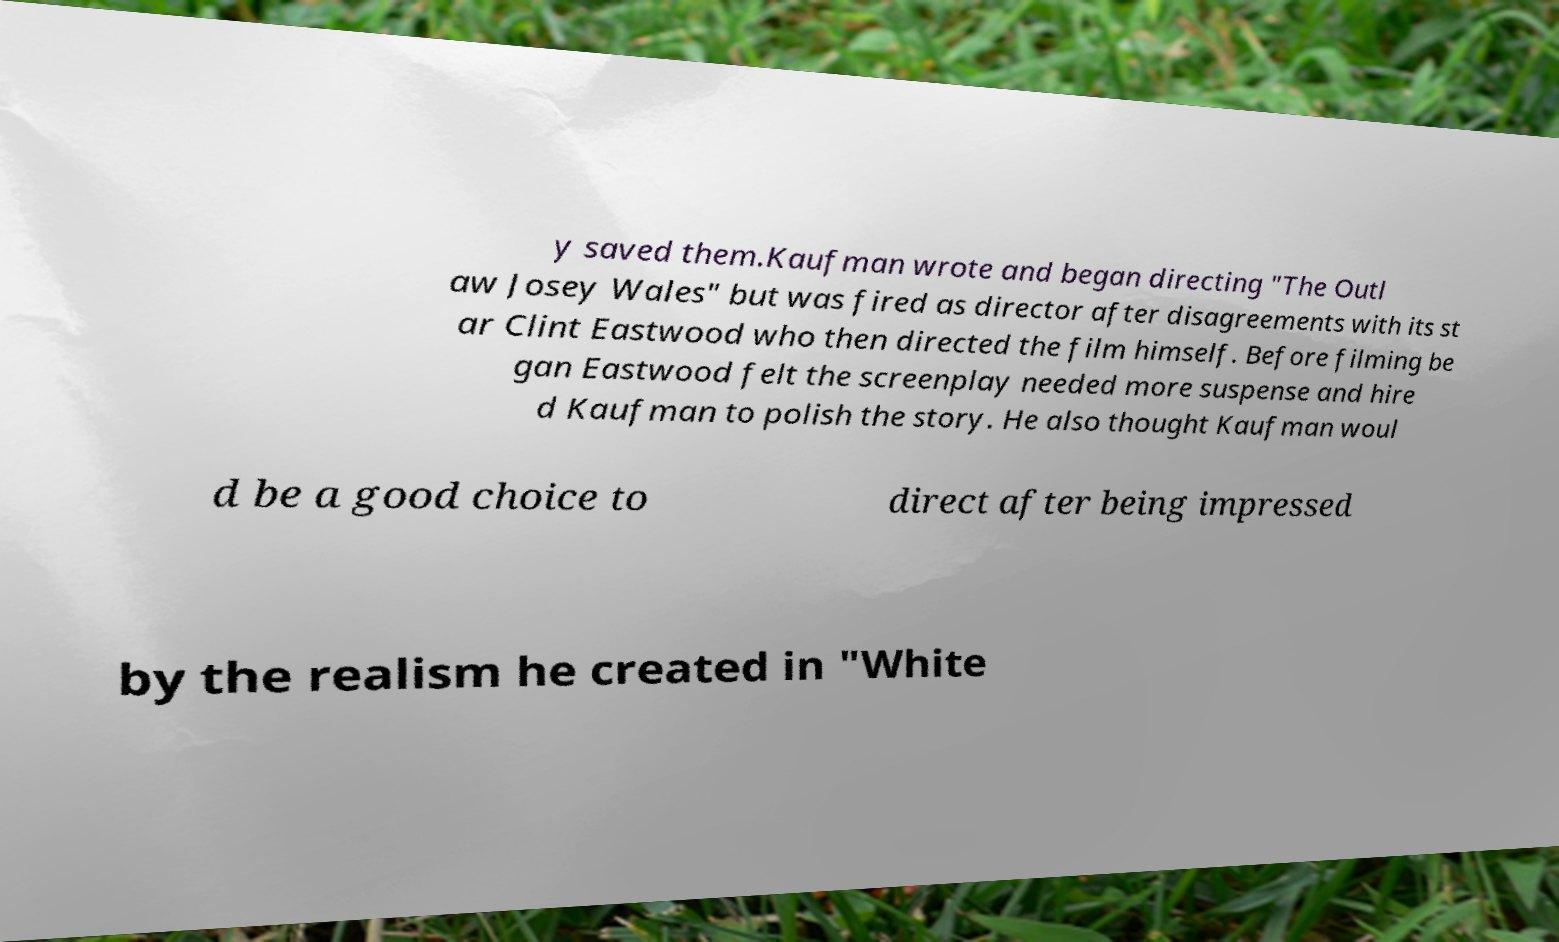Can you read and provide the text displayed in the image?This photo seems to have some interesting text. Can you extract and type it out for me? y saved them.Kaufman wrote and began directing "The Outl aw Josey Wales" but was fired as director after disagreements with its st ar Clint Eastwood who then directed the film himself. Before filming be gan Eastwood felt the screenplay needed more suspense and hire d Kaufman to polish the story. He also thought Kaufman woul d be a good choice to direct after being impressed by the realism he created in "White 